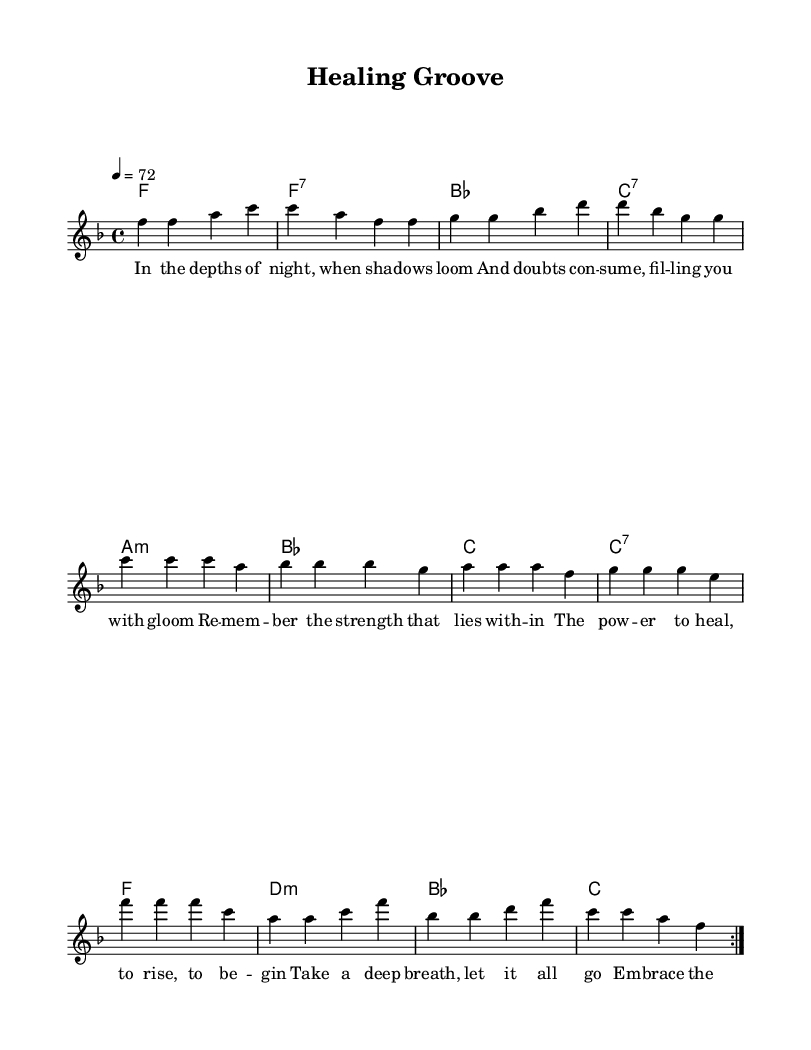What is the key signature of this music? The key signature is F major, which has one flat (B flat).
Answer: F major What is the time signature of this music? The time signature is 4/4, indicating four beats per measure.
Answer: 4/4 What is the tempo marking of the piece? The tempo marking is 72 beats per minute, indicated as quarter note equals 72.
Answer: 72 How many measures are in the repeated section of the melody? The repeated section of the melody contains 8 measures as indicated by the volta signs.
Answer: 8 What are the primary emotional themes expressed in the lyrics? The themes include strength, healing, and resilience amidst emotional turmoil.
Answer: Strength, healing, resilience How does the rhythm contribute to the song’s disco genre? The consistent 4/4 time signature alongside syncopated rhythms provides a danceable groove typical of disco music.
Answer: Danceable groove What is the main direction of the chorus in terms of emotional healing? The chorus encourages listeners to dance through their pain and allows music to facilitate healing.
Answer: Dance through the pain 